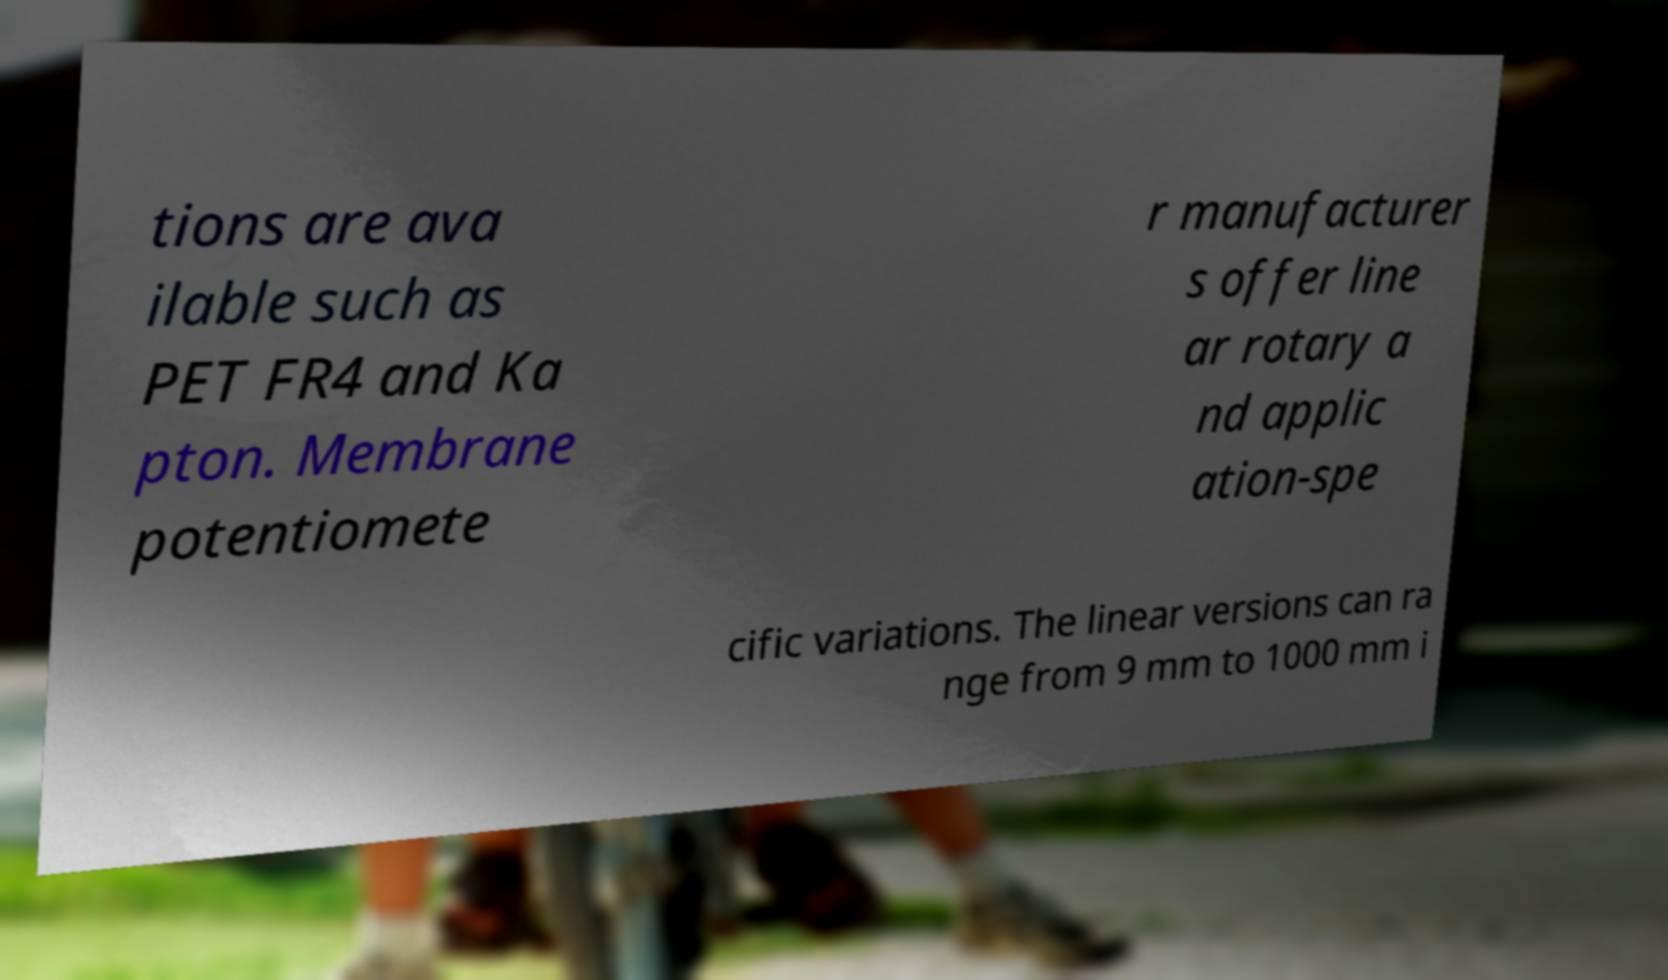I need the written content from this picture converted into text. Can you do that? tions are ava ilable such as PET FR4 and Ka pton. Membrane potentiomete r manufacturer s offer line ar rotary a nd applic ation-spe cific variations. The linear versions can ra nge from 9 mm to 1000 mm i 